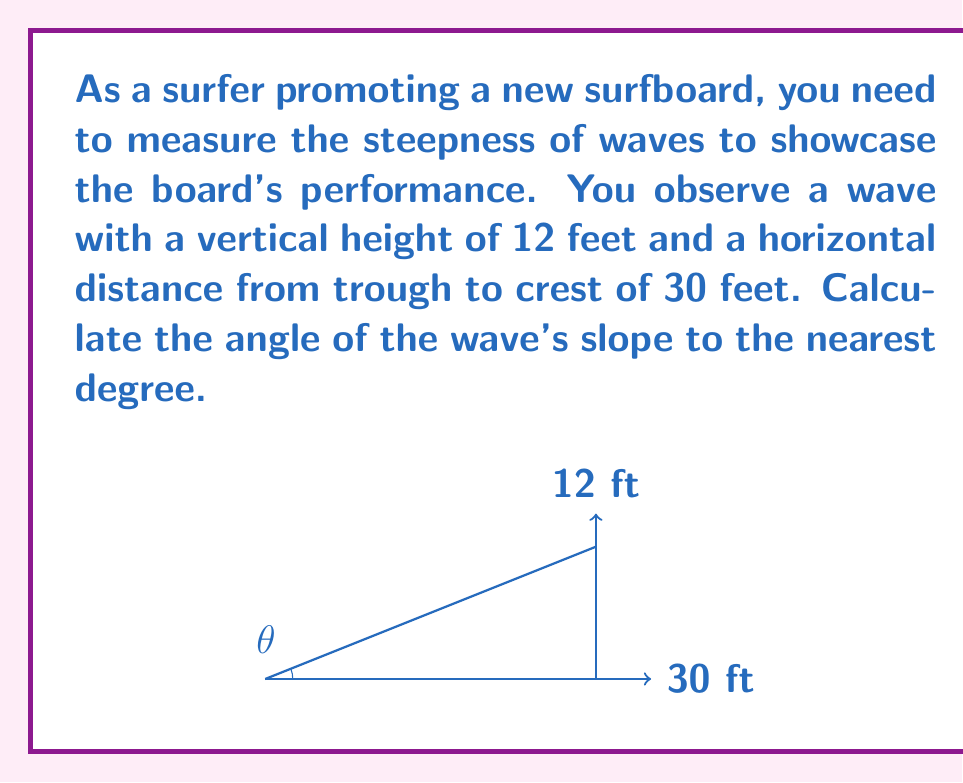Help me with this question. To solve this problem, we'll use trigonometry, specifically the tangent function. The tangent of an angle in a right triangle is the ratio of the opposite side to the adjacent side.

1) In this case, we have a right triangle where:
   - The opposite side (wave height) is 12 feet
   - The adjacent side (horizontal distance) is 30 feet
   - We need to find the angle $\theta$

2) The tangent of the angle $\theta$ is:

   $$\tan(\theta) = \frac{\text{opposite}}{\text{adjacent}} = \frac{12}{30} = 0.4$$

3) To find the angle, we need to use the inverse tangent (arctan or $\tan^{-1}$):

   $$\theta = \tan^{-1}(0.4)$$

4) Using a calculator or trigonometric tables:

   $$\theta \approx 21.80^\circ$$

5) Rounding to the nearest degree:

   $$\theta \approx 22^\circ$$

Therefore, the angle of the wave's slope is approximately 22 degrees.
Answer: 22° 